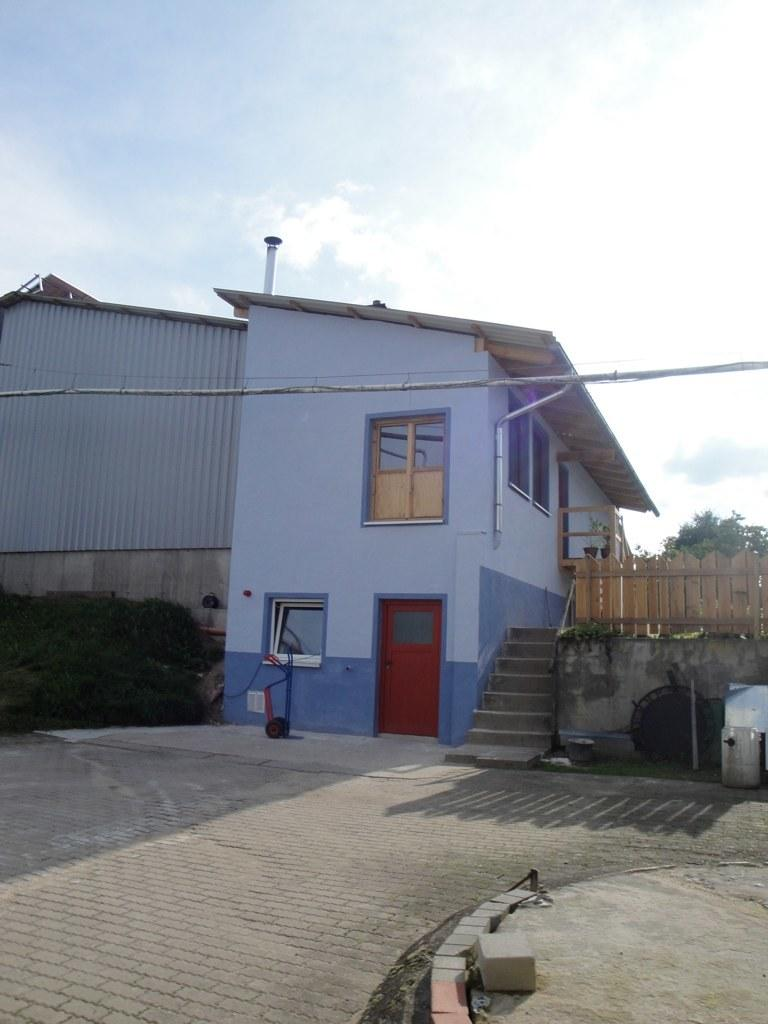What is the main subject in the center of the image? There is a house in the center of the image. What type of vegetation can be seen in the image? There are trees in the image. What is visible at the top of the image? The sky is visible at the top of the image. What type of produce is being harvested in the image? There is no produce or harvesting activity present in the image; it features a house, trees, and the sky. What color is the silverware used for the meal in the image? There is no silverware or meal present in the image. 